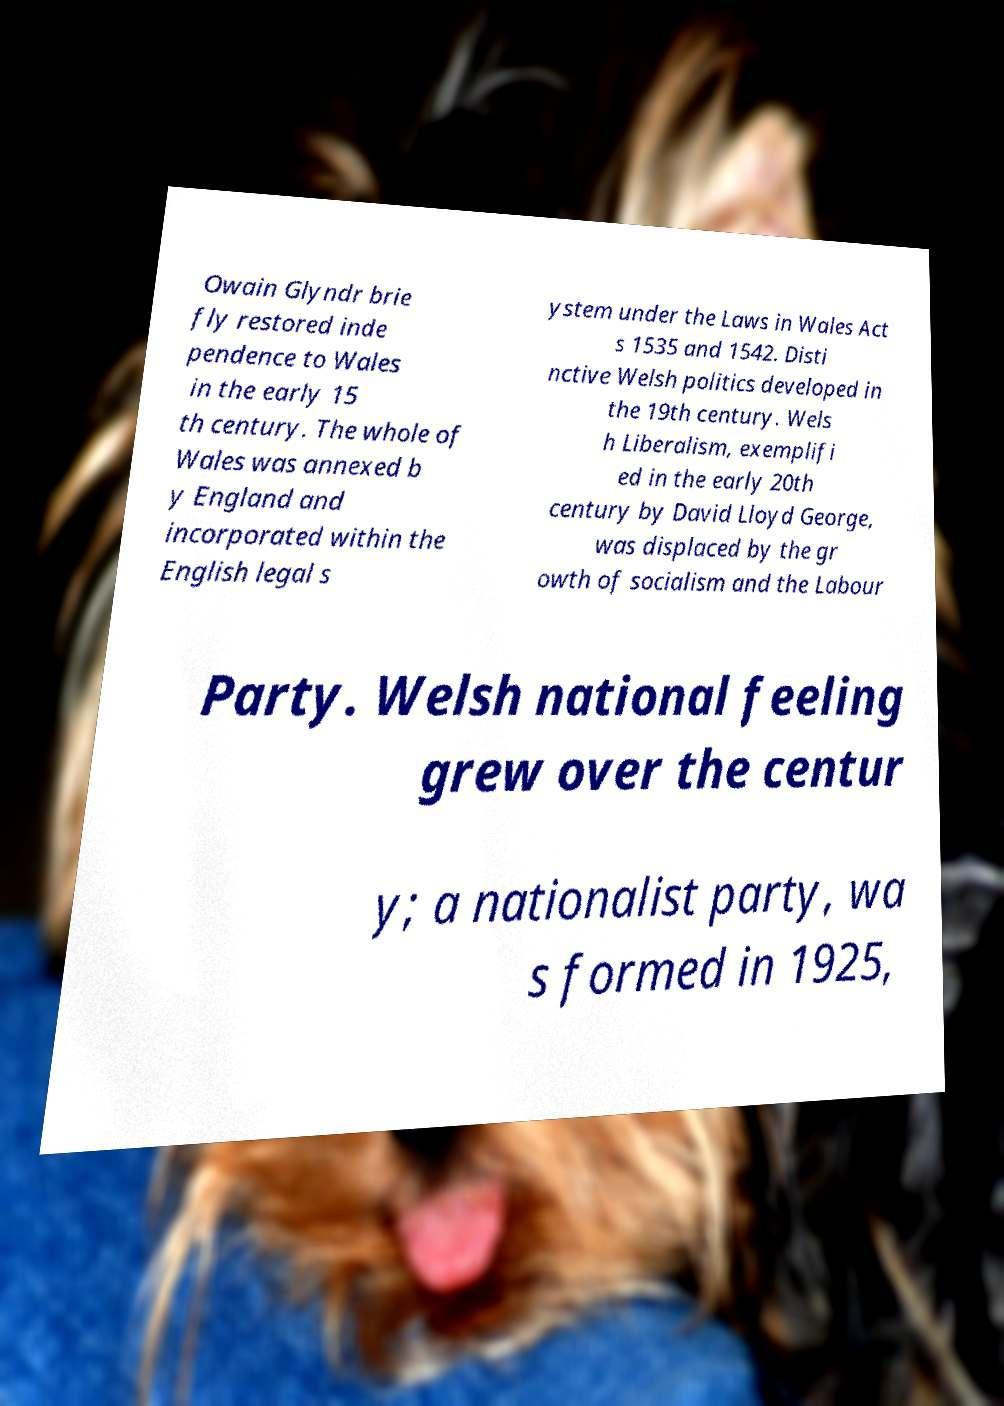I need the written content from this picture converted into text. Can you do that? Owain Glyndr brie fly restored inde pendence to Wales in the early 15 th century. The whole of Wales was annexed b y England and incorporated within the English legal s ystem under the Laws in Wales Act s 1535 and 1542. Disti nctive Welsh politics developed in the 19th century. Wels h Liberalism, exemplifi ed in the early 20th century by David Lloyd George, was displaced by the gr owth of socialism and the Labour Party. Welsh national feeling grew over the centur y; a nationalist party, wa s formed in 1925, 